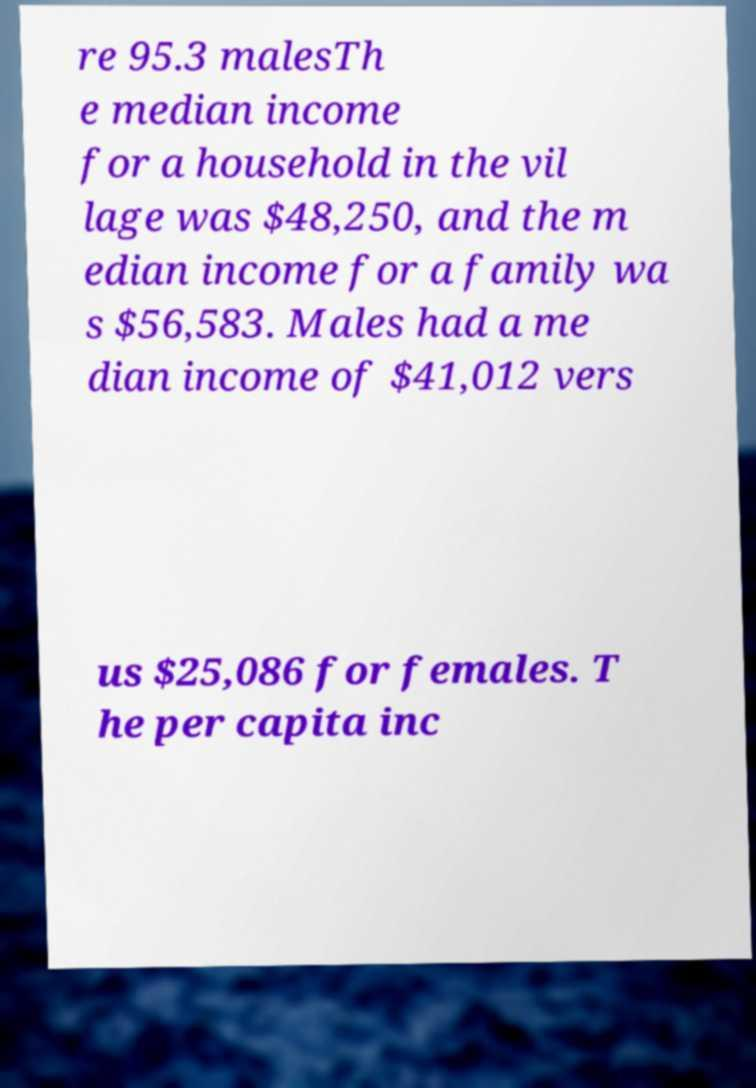Please read and relay the text visible in this image. What does it say? re 95.3 malesTh e median income for a household in the vil lage was $48,250, and the m edian income for a family wa s $56,583. Males had a me dian income of $41,012 vers us $25,086 for females. T he per capita inc 